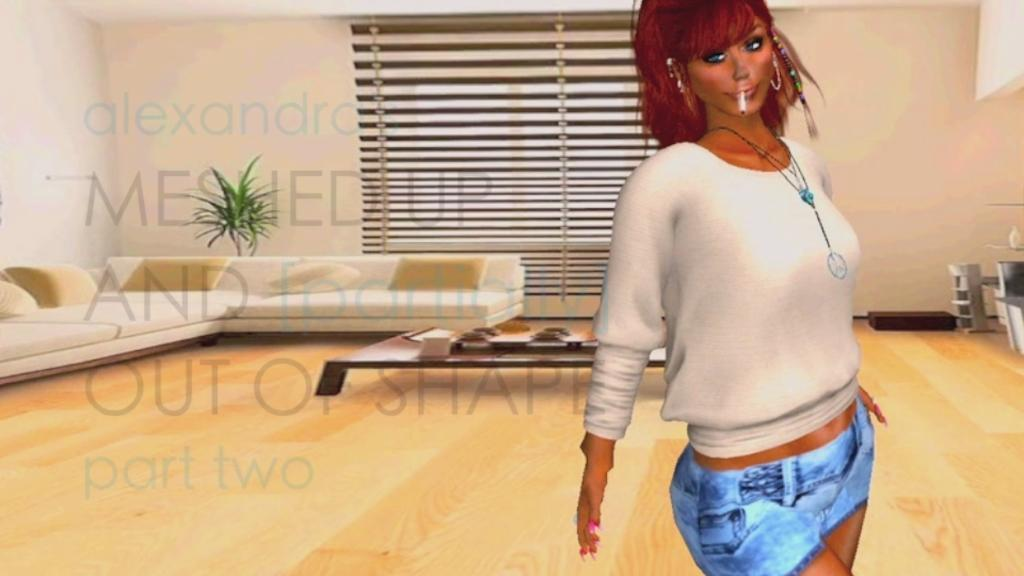What type of image is being described? The image is animated. Can you describe the main subject in the image? There is a woman standing in the center of the image. What can be seen in the background of the image? There are sofas and a table in the background of the image. What type of ornament is hanging from the ceiling in the image? There is no ornament hanging from the ceiling in the image. Can you tell me how many tents are visible in the image? There are no tents present in the image. 